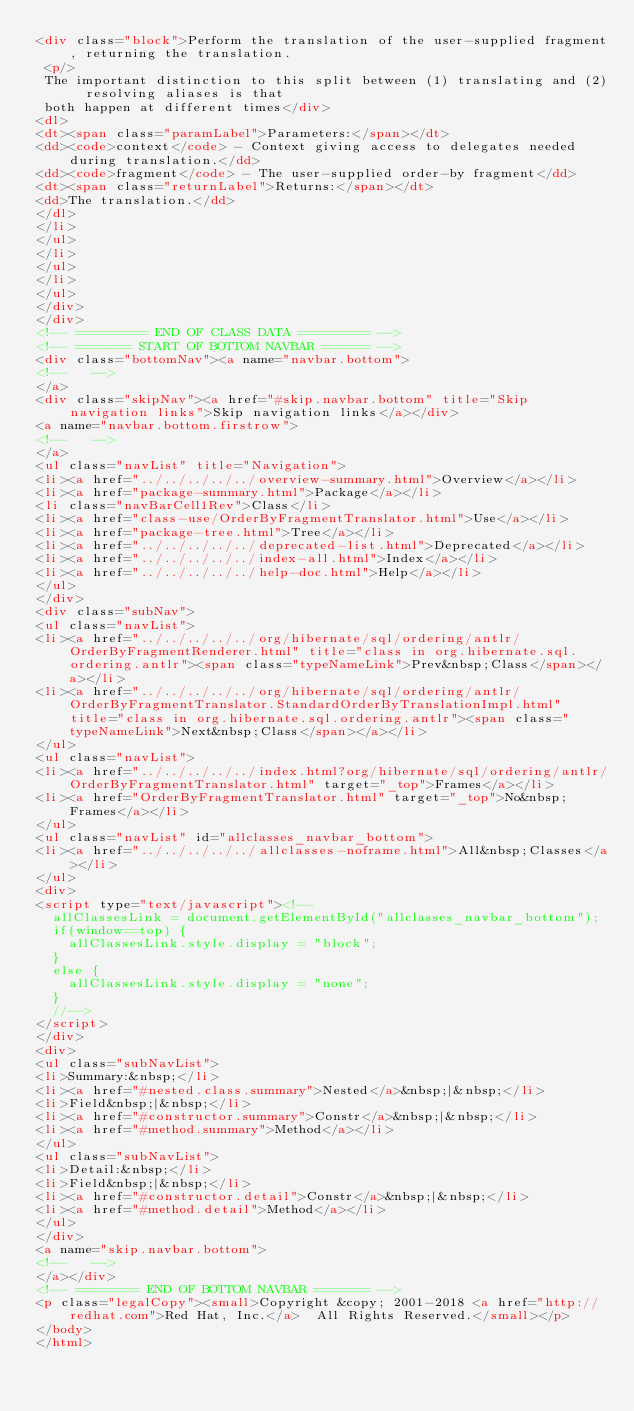Convert code to text. <code><loc_0><loc_0><loc_500><loc_500><_HTML_><div class="block">Perform the translation of the user-supplied fragment, returning the translation.
 <p/>
 The important distinction to this split between (1) translating and (2) resolving aliases is that
 both happen at different times</div>
<dl>
<dt><span class="paramLabel">Parameters:</span></dt>
<dd><code>context</code> - Context giving access to delegates needed during translation.</dd>
<dd><code>fragment</code> - The user-supplied order-by fragment</dd>
<dt><span class="returnLabel">Returns:</span></dt>
<dd>The translation.</dd>
</dl>
</li>
</ul>
</li>
</ul>
</li>
</ul>
</div>
</div>
<!-- ========= END OF CLASS DATA ========= -->
<!-- ======= START OF BOTTOM NAVBAR ====== -->
<div class="bottomNav"><a name="navbar.bottom">
<!--   -->
</a>
<div class="skipNav"><a href="#skip.navbar.bottom" title="Skip navigation links">Skip navigation links</a></div>
<a name="navbar.bottom.firstrow">
<!--   -->
</a>
<ul class="navList" title="Navigation">
<li><a href="../../../../../overview-summary.html">Overview</a></li>
<li><a href="package-summary.html">Package</a></li>
<li class="navBarCell1Rev">Class</li>
<li><a href="class-use/OrderByFragmentTranslator.html">Use</a></li>
<li><a href="package-tree.html">Tree</a></li>
<li><a href="../../../../../deprecated-list.html">Deprecated</a></li>
<li><a href="../../../../../index-all.html">Index</a></li>
<li><a href="../../../../../help-doc.html">Help</a></li>
</ul>
</div>
<div class="subNav">
<ul class="navList">
<li><a href="../../../../../org/hibernate/sql/ordering/antlr/OrderByFragmentRenderer.html" title="class in org.hibernate.sql.ordering.antlr"><span class="typeNameLink">Prev&nbsp;Class</span></a></li>
<li><a href="../../../../../org/hibernate/sql/ordering/antlr/OrderByFragmentTranslator.StandardOrderByTranslationImpl.html" title="class in org.hibernate.sql.ordering.antlr"><span class="typeNameLink">Next&nbsp;Class</span></a></li>
</ul>
<ul class="navList">
<li><a href="../../../../../index.html?org/hibernate/sql/ordering/antlr/OrderByFragmentTranslator.html" target="_top">Frames</a></li>
<li><a href="OrderByFragmentTranslator.html" target="_top">No&nbsp;Frames</a></li>
</ul>
<ul class="navList" id="allclasses_navbar_bottom">
<li><a href="../../../../../allclasses-noframe.html">All&nbsp;Classes</a></li>
</ul>
<div>
<script type="text/javascript"><!--
  allClassesLink = document.getElementById("allclasses_navbar_bottom");
  if(window==top) {
    allClassesLink.style.display = "block";
  }
  else {
    allClassesLink.style.display = "none";
  }
  //-->
</script>
</div>
<div>
<ul class="subNavList">
<li>Summary:&nbsp;</li>
<li><a href="#nested.class.summary">Nested</a>&nbsp;|&nbsp;</li>
<li>Field&nbsp;|&nbsp;</li>
<li><a href="#constructor.summary">Constr</a>&nbsp;|&nbsp;</li>
<li><a href="#method.summary">Method</a></li>
</ul>
<ul class="subNavList">
<li>Detail:&nbsp;</li>
<li>Field&nbsp;|&nbsp;</li>
<li><a href="#constructor.detail">Constr</a>&nbsp;|&nbsp;</li>
<li><a href="#method.detail">Method</a></li>
</ul>
</div>
<a name="skip.navbar.bottom">
<!--   -->
</a></div>
<!-- ======== END OF BOTTOM NAVBAR ======= -->
<p class="legalCopy"><small>Copyright &copy; 2001-2018 <a href="http://redhat.com">Red Hat, Inc.</a>  All Rights Reserved.</small></p>
</body>
</html>
</code> 